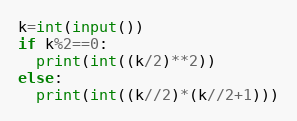Convert code to text. <code><loc_0><loc_0><loc_500><loc_500><_Python_>k=int(input())
if k%2==0:
  print(int((k/2)**2))
else:
  print(int((k//2)*(k//2+1)))</code> 